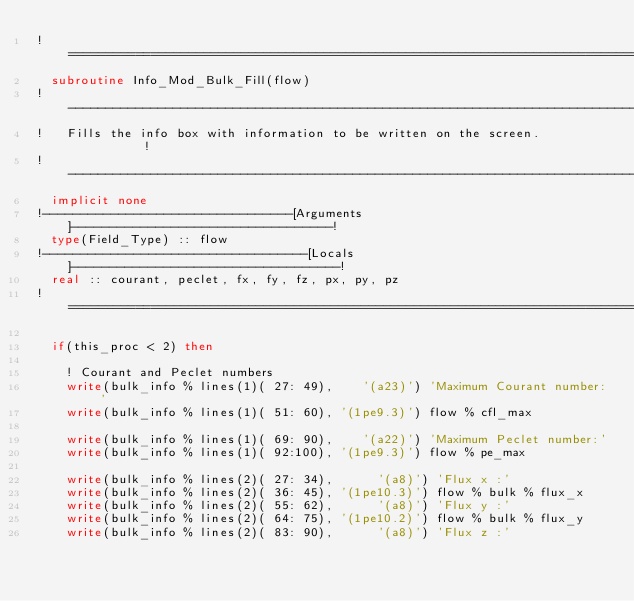<code> <loc_0><loc_0><loc_500><loc_500><_FORTRAN_>!==============================================================================!
  subroutine Info_Mod_Bulk_Fill(flow)
!------------------------------------------------------------------------------!
!   Fills the info box with information to be written on the screen.           !
!------------------------------------------------------------------------------!
  implicit none
!---------------------------------[Arguments]----------------------------------!
  type(Field_Type) :: flow
!-----------------------------------[Locals]-----------------------------------!
  real :: courant, peclet, fx, fy, fz, px, py, pz
!==============================================================================!

  if(this_proc < 2) then

    ! Courant and Peclet numbers
    write(bulk_info % lines(1)( 27: 49),    '(a23)') 'Maximum Courant number:'
    write(bulk_info % lines(1)( 51: 60), '(1pe9.3)') flow % cfl_max

    write(bulk_info % lines(1)( 69: 90),    '(a22)') 'Maximum Peclet number:'
    write(bulk_info % lines(1)( 92:100), '(1pe9.3)') flow % pe_max

    write(bulk_info % lines(2)( 27: 34),      '(a8)') 'Flux x :'
    write(bulk_info % lines(2)( 36: 45), '(1pe10.3)') flow % bulk % flux_x
    write(bulk_info % lines(2)( 55: 62),      '(a8)') 'Flux y :'
    write(bulk_info % lines(2)( 64: 75), '(1pe10.2)') flow % bulk % flux_y
    write(bulk_info % lines(2)( 83: 90),      '(a8)') 'Flux z :'</code> 